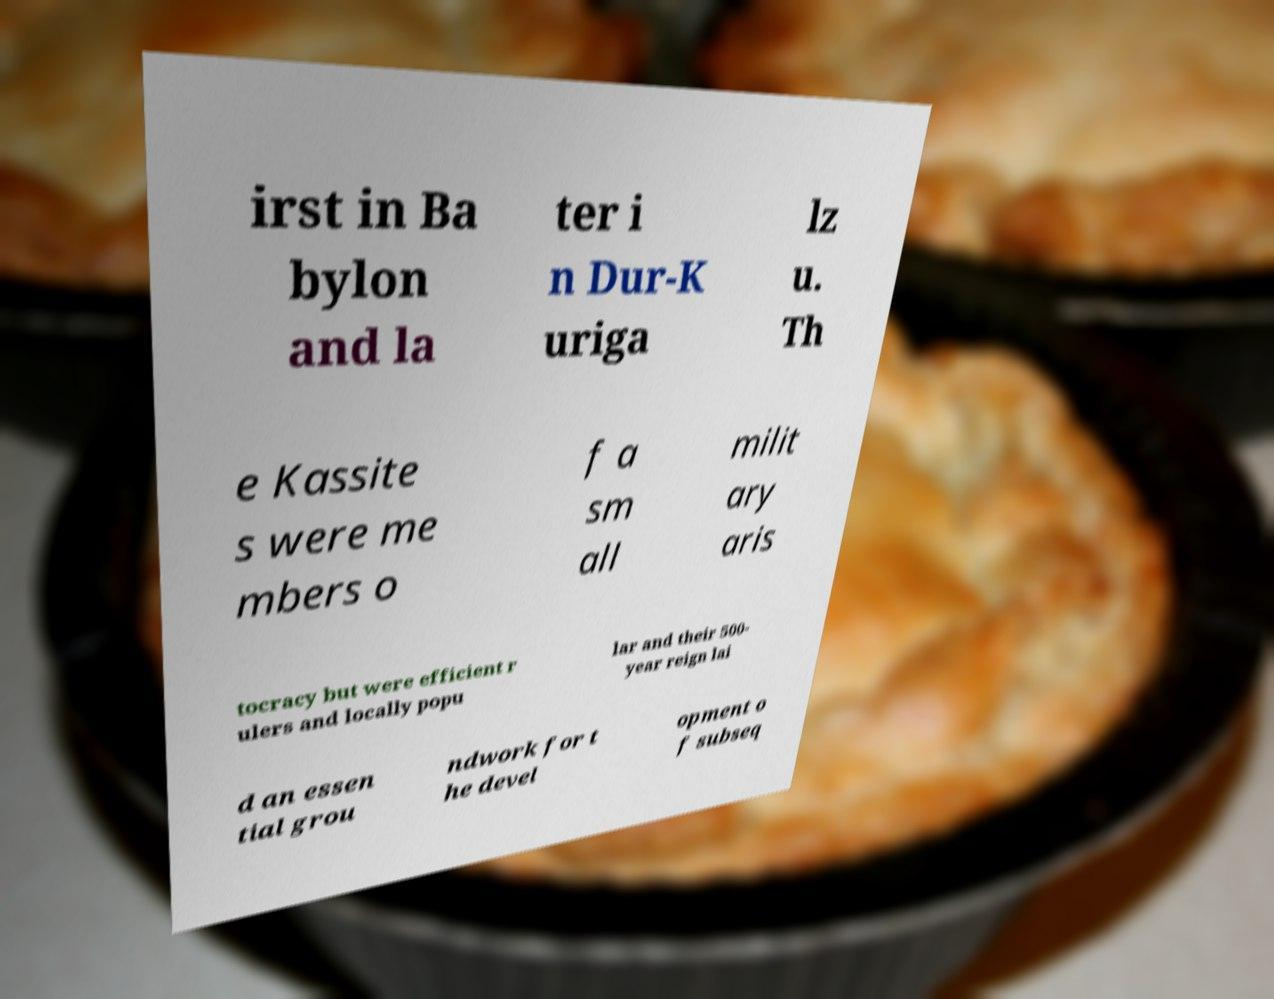Could you assist in decoding the text presented in this image and type it out clearly? irst in Ba bylon and la ter i n Dur-K uriga lz u. Th e Kassite s were me mbers o f a sm all milit ary aris tocracy but were efficient r ulers and locally popu lar and their 500- year reign lai d an essen tial grou ndwork for t he devel opment o f subseq 